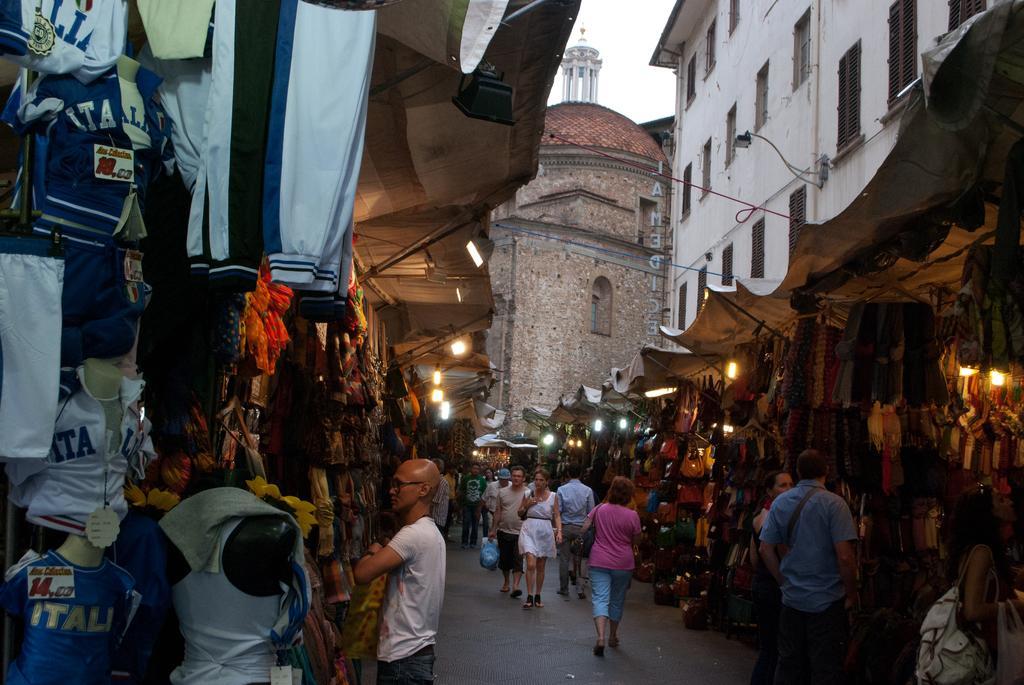Can you describe this image briefly? This picture describes about group of people, few are standing and few are walking, beside to them we can find few clothes, bags, lights and tents, in the background we can see few buildings. 